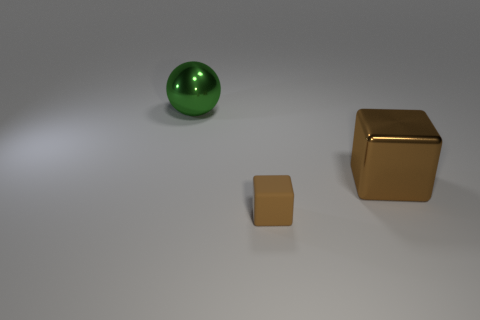The metal ball that is the same size as the metal block is what color?
Your response must be concise. Green. What number of other brown matte things are the same shape as the small brown rubber thing?
Offer a terse response. 0. What number of cubes are small brown matte objects or big matte objects?
Your response must be concise. 1. Does the large metal object that is to the right of the small brown matte cube have the same shape as the large metallic object to the left of the small rubber cube?
Your response must be concise. No. What is the material of the big green object?
Provide a succinct answer. Metal. There is a large metallic object that is the same color as the small object; what is its shape?
Give a very brief answer. Cube. How many brown shiny blocks are the same size as the green metal thing?
Provide a short and direct response. 1. What number of objects are either brown objects that are on the right side of the tiny matte object or things that are to the left of the metallic cube?
Provide a succinct answer. 3. Does the block left of the large block have the same material as the big object to the right of the big green sphere?
Provide a succinct answer. No. What shape is the metallic thing in front of the metal object that is on the left side of the small matte object?
Your answer should be compact. Cube. 